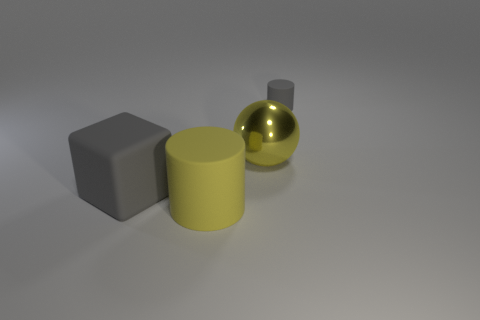Is there a tiny gray thing made of the same material as the big cube?
Offer a terse response. Yes. Are the gray cylinder and the yellow sphere made of the same material?
Provide a succinct answer. No. There is a cylinder that is the same size as the yellow metal sphere; what is its color?
Your answer should be very brief. Yellow. How many other things are there of the same shape as the large yellow metal object?
Your answer should be compact. 0. Do the rubber block and the yellow thing behind the yellow cylinder have the same size?
Give a very brief answer. Yes. How many things are large yellow shiny objects or small gray metal balls?
Make the answer very short. 1. What number of other things are there of the same size as the metallic object?
Provide a short and direct response. 2. Do the rubber cube and the matte cylinder that is behind the big yellow matte thing have the same color?
Provide a succinct answer. Yes. What number of spheres are big yellow objects or gray rubber things?
Your answer should be compact. 1. Is there any other thing of the same color as the small matte cylinder?
Give a very brief answer. Yes. 